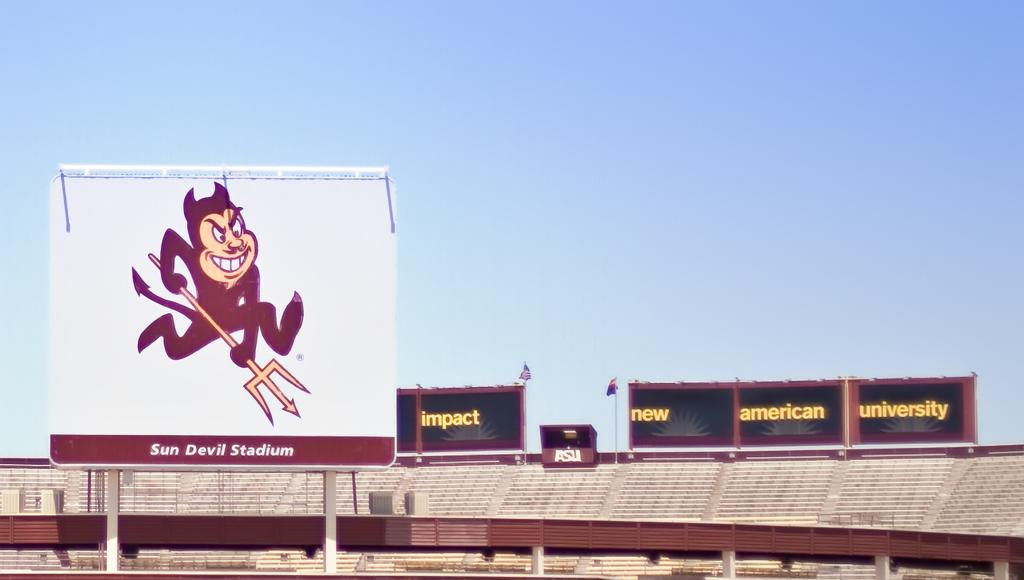<image>
Provide a brief description of the given image. An open empty stadium with an image of a cartoon devil holding a pitchfork on top. 